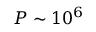Convert formula to latex. <formula><loc_0><loc_0><loc_500><loc_500>P \sim 1 0 ^ { 6 }</formula> 